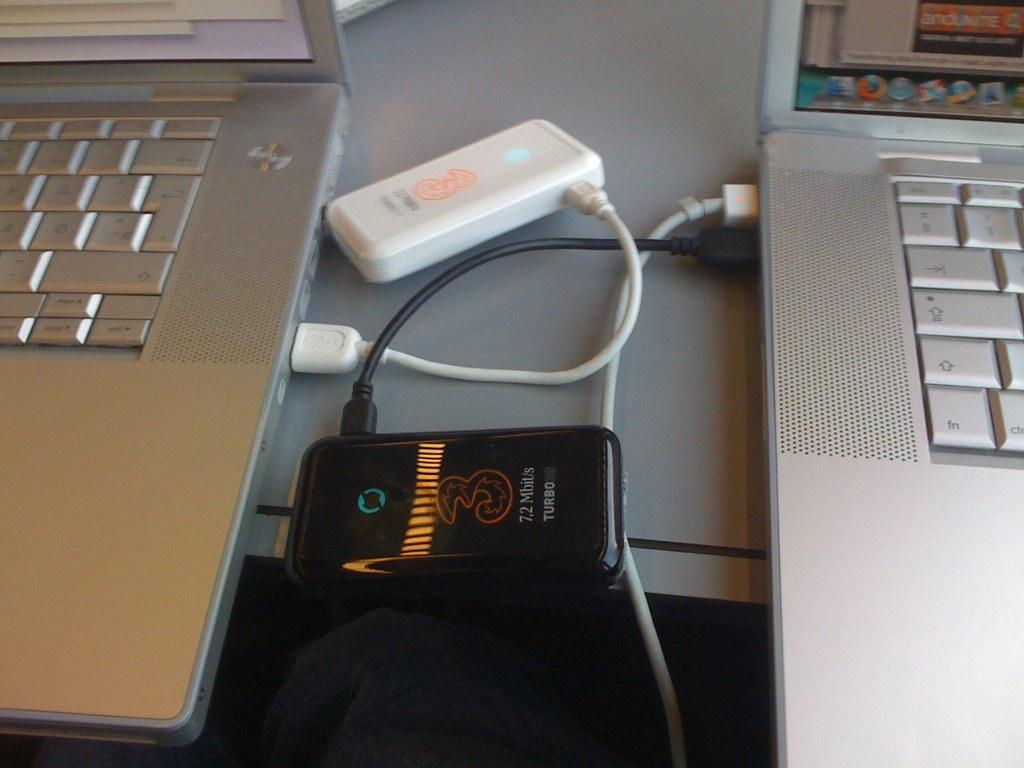<image>
Provide a brief description of the given image. A black device displaying internet speed of 7,2 Mbit/s turbo 30 